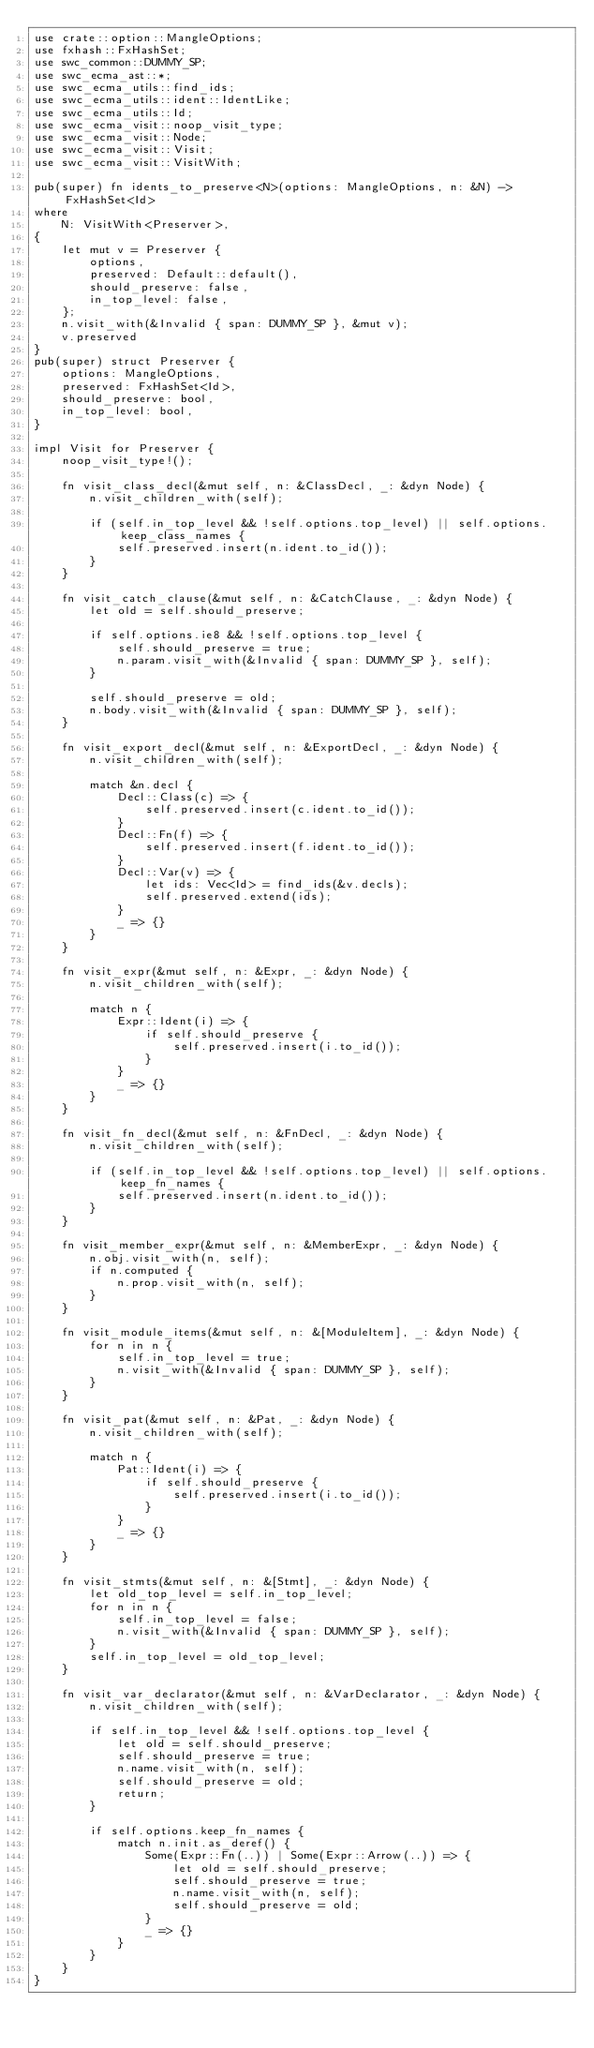Convert code to text. <code><loc_0><loc_0><loc_500><loc_500><_Rust_>use crate::option::MangleOptions;
use fxhash::FxHashSet;
use swc_common::DUMMY_SP;
use swc_ecma_ast::*;
use swc_ecma_utils::find_ids;
use swc_ecma_utils::ident::IdentLike;
use swc_ecma_utils::Id;
use swc_ecma_visit::noop_visit_type;
use swc_ecma_visit::Node;
use swc_ecma_visit::Visit;
use swc_ecma_visit::VisitWith;

pub(super) fn idents_to_preserve<N>(options: MangleOptions, n: &N) -> FxHashSet<Id>
where
    N: VisitWith<Preserver>,
{
    let mut v = Preserver {
        options,
        preserved: Default::default(),
        should_preserve: false,
        in_top_level: false,
    };
    n.visit_with(&Invalid { span: DUMMY_SP }, &mut v);
    v.preserved
}
pub(super) struct Preserver {
    options: MangleOptions,
    preserved: FxHashSet<Id>,
    should_preserve: bool,
    in_top_level: bool,
}

impl Visit for Preserver {
    noop_visit_type!();

    fn visit_class_decl(&mut self, n: &ClassDecl, _: &dyn Node) {
        n.visit_children_with(self);

        if (self.in_top_level && !self.options.top_level) || self.options.keep_class_names {
            self.preserved.insert(n.ident.to_id());
        }
    }

    fn visit_catch_clause(&mut self, n: &CatchClause, _: &dyn Node) {
        let old = self.should_preserve;

        if self.options.ie8 && !self.options.top_level {
            self.should_preserve = true;
            n.param.visit_with(&Invalid { span: DUMMY_SP }, self);
        }

        self.should_preserve = old;
        n.body.visit_with(&Invalid { span: DUMMY_SP }, self);
    }

    fn visit_export_decl(&mut self, n: &ExportDecl, _: &dyn Node) {
        n.visit_children_with(self);

        match &n.decl {
            Decl::Class(c) => {
                self.preserved.insert(c.ident.to_id());
            }
            Decl::Fn(f) => {
                self.preserved.insert(f.ident.to_id());
            }
            Decl::Var(v) => {
                let ids: Vec<Id> = find_ids(&v.decls);
                self.preserved.extend(ids);
            }
            _ => {}
        }
    }

    fn visit_expr(&mut self, n: &Expr, _: &dyn Node) {
        n.visit_children_with(self);

        match n {
            Expr::Ident(i) => {
                if self.should_preserve {
                    self.preserved.insert(i.to_id());
                }
            }
            _ => {}
        }
    }

    fn visit_fn_decl(&mut self, n: &FnDecl, _: &dyn Node) {
        n.visit_children_with(self);

        if (self.in_top_level && !self.options.top_level) || self.options.keep_fn_names {
            self.preserved.insert(n.ident.to_id());
        }
    }

    fn visit_member_expr(&mut self, n: &MemberExpr, _: &dyn Node) {
        n.obj.visit_with(n, self);
        if n.computed {
            n.prop.visit_with(n, self);
        }
    }

    fn visit_module_items(&mut self, n: &[ModuleItem], _: &dyn Node) {
        for n in n {
            self.in_top_level = true;
            n.visit_with(&Invalid { span: DUMMY_SP }, self);
        }
    }

    fn visit_pat(&mut self, n: &Pat, _: &dyn Node) {
        n.visit_children_with(self);

        match n {
            Pat::Ident(i) => {
                if self.should_preserve {
                    self.preserved.insert(i.to_id());
                }
            }
            _ => {}
        }
    }

    fn visit_stmts(&mut self, n: &[Stmt], _: &dyn Node) {
        let old_top_level = self.in_top_level;
        for n in n {
            self.in_top_level = false;
            n.visit_with(&Invalid { span: DUMMY_SP }, self);
        }
        self.in_top_level = old_top_level;
    }

    fn visit_var_declarator(&mut self, n: &VarDeclarator, _: &dyn Node) {
        n.visit_children_with(self);

        if self.in_top_level && !self.options.top_level {
            let old = self.should_preserve;
            self.should_preserve = true;
            n.name.visit_with(n, self);
            self.should_preserve = old;
            return;
        }

        if self.options.keep_fn_names {
            match n.init.as_deref() {
                Some(Expr::Fn(..)) | Some(Expr::Arrow(..)) => {
                    let old = self.should_preserve;
                    self.should_preserve = true;
                    n.name.visit_with(n, self);
                    self.should_preserve = old;
                }
                _ => {}
            }
        }
    }
}
</code> 